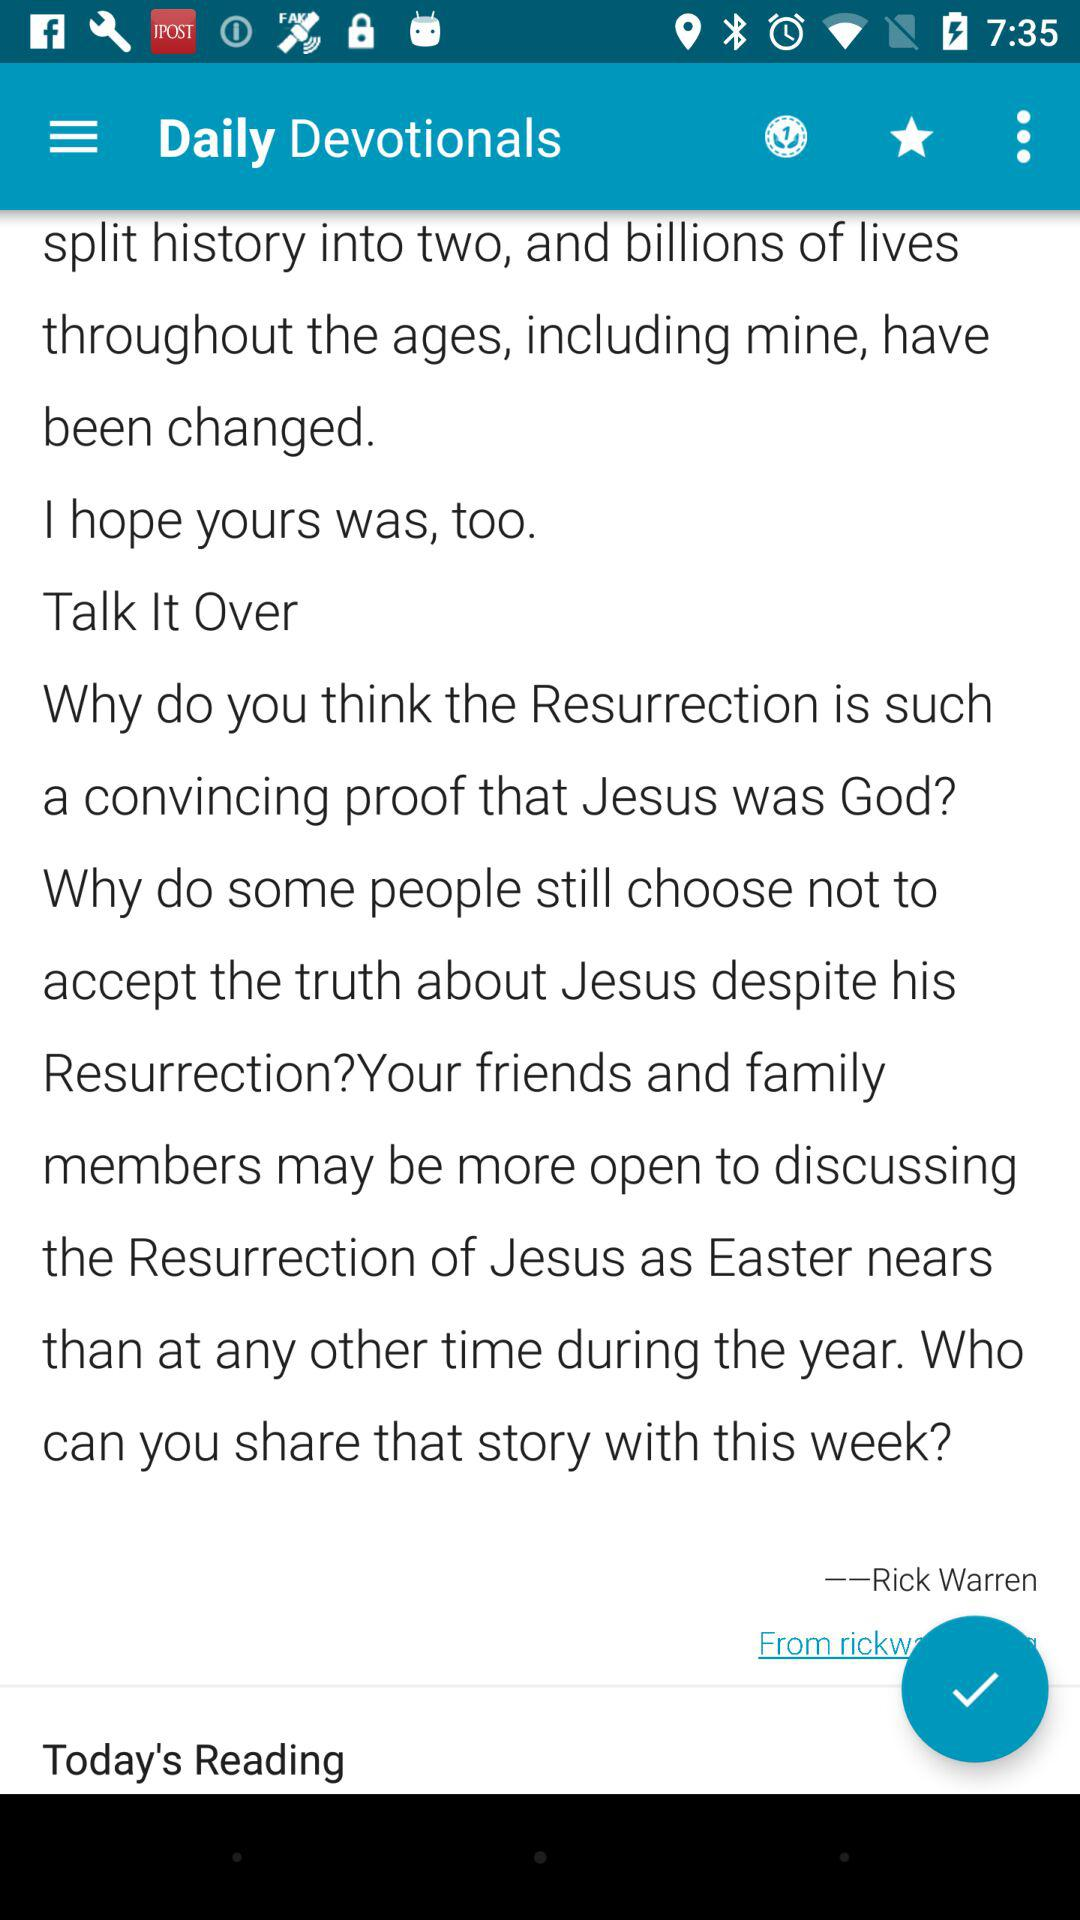What is the name of the application? The name of the application is "Daily Devotionals". 